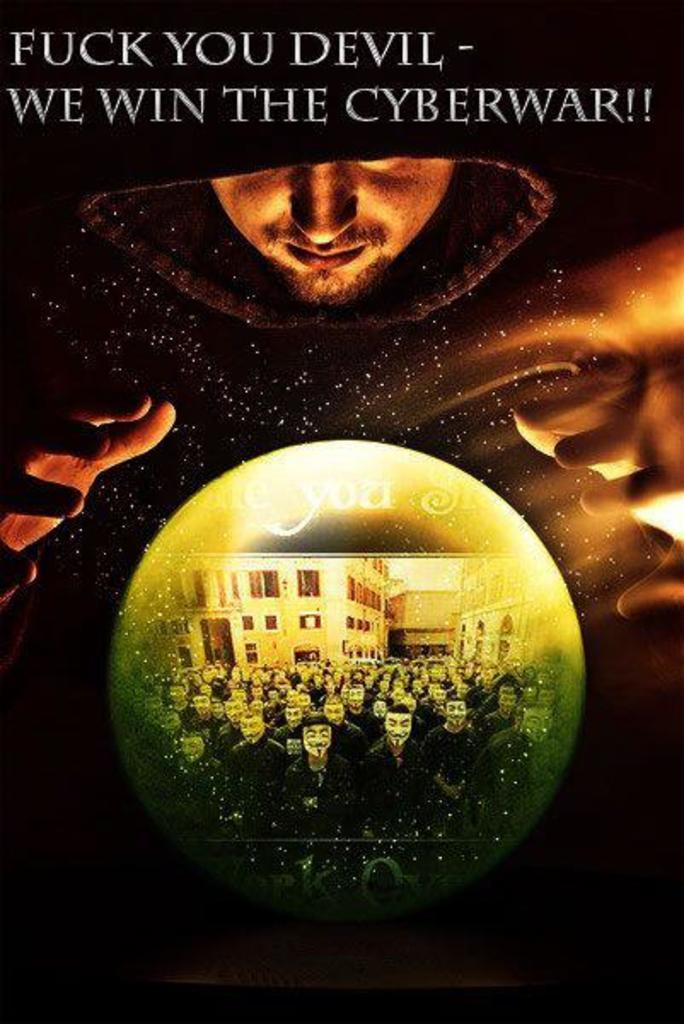<image>
Share a concise interpretation of the image provided. A poster shows a man using a crystal ball under the heading We Win the Cyberwar!! 